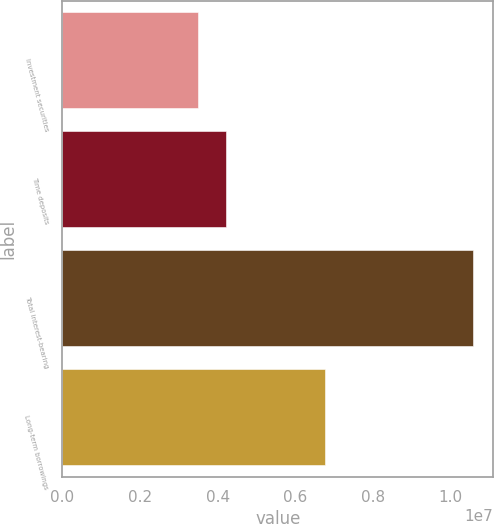<chart> <loc_0><loc_0><loc_500><loc_500><bar_chart><fcel>Investment securities<fcel>Time deposits<fcel>Total interest-bearing<fcel>Long-term borrowings<nl><fcel>3.50202e+06<fcel>4.20863e+06<fcel>1.05681e+07<fcel>6.76605e+06<nl></chart> 